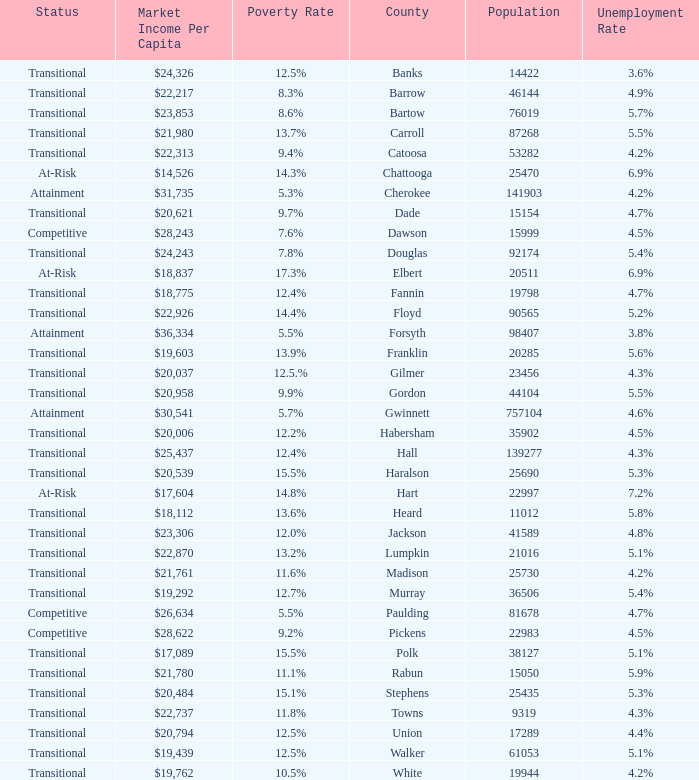What is the market income per capita of the county with the 9.4% poverty rate? $22,313. 